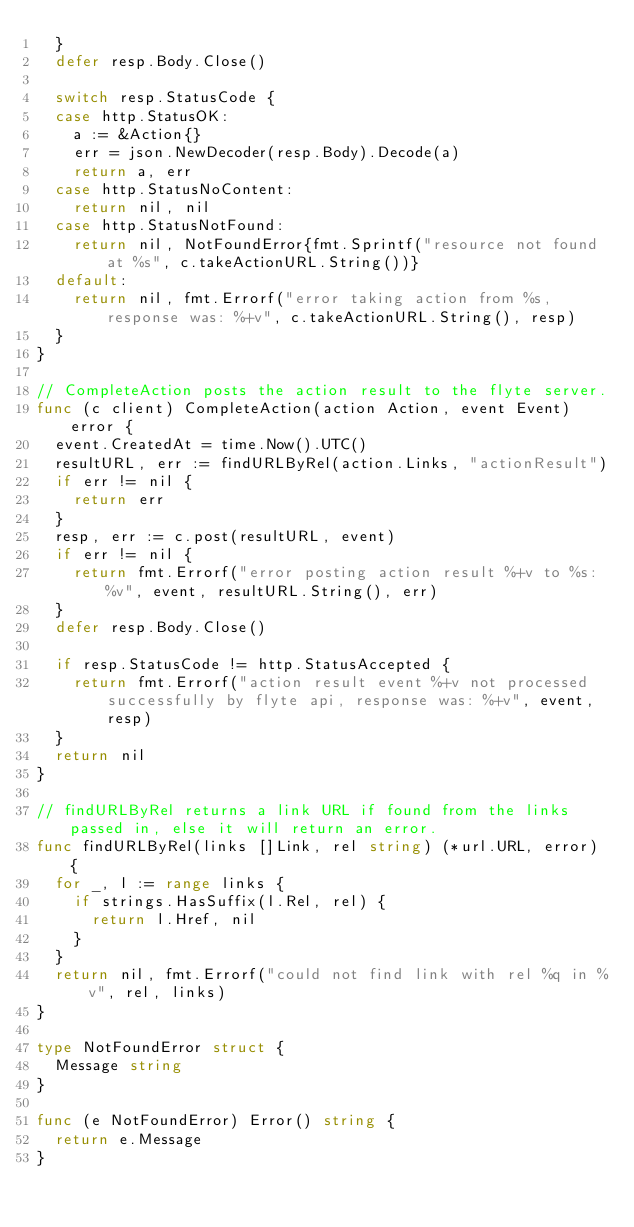<code> <loc_0><loc_0><loc_500><loc_500><_Go_>	}
	defer resp.Body.Close()

	switch resp.StatusCode {
	case http.StatusOK:
		a := &Action{}
		err = json.NewDecoder(resp.Body).Decode(a)
		return a, err
	case http.StatusNoContent:
		return nil, nil
	case http.StatusNotFound:
		return nil, NotFoundError{fmt.Sprintf("resource not found at %s", c.takeActionURL.String())}
	default:
		return nil, fmt.Errorf("error taking action from %s, response was: %+v", c.takeActionURL.String(), resp)
	}
}

// CompleteAction posts the action result to the flyte server.
func (c client) CompleteAction(action Action, event Event) error {
	event.CreatedAt = time.Now().UTC()
	resultURL, err := findURLByRel(action.Links, "actionResult")
	if err != nil {
		return err
	}
	resp, err := c.post(resultURL, event)
	if err != nil {
		return fmt.Errorf("error posting action result %+v to %s: %v", event, resultURL.String(), err)
	}
	defer resp.Body.Close()

	if resp.StatusCode != http.StatusAccepted {
		return fmt.Errorf("action result event %+v not processed successfully by flyte api, response was: %+v", event, resp)
	}
	return nil
}

// findURLByRel returns a link URL if found from the links passed in, else it will return an error.
func findURLByRel(links []Link, rel string) (*url.URL, error) {
	for _, l := range links {
		if strings.HasSuffix(l.Rel, rel) {
			return l.Href, nil
		}
	}
	return nil, fmt.Errorf("could not find link with rel %q in %v", rel, links)
}

type NotFoundError struct {
	Message string
}

func (e NotFoundError) Error() string {
	return e.Message
}
</code> 